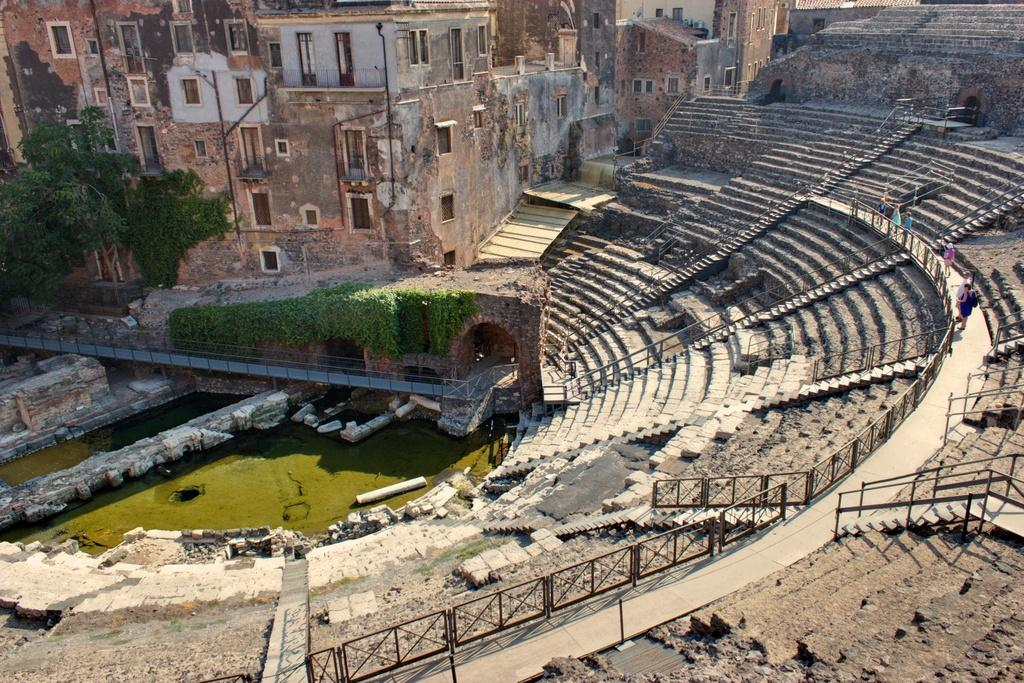What type of structure is visible in the image? There is a building in the image. What is located in front of the building? There are trees and a pond in front of the building. What features are present around the pond? There are stairs and a railing around the pond. What type of nail can be seen in the image? There is no nail present in the image. What disease is affecting the trees in the image? There is no indication of any disease affecting the trees in the image. 